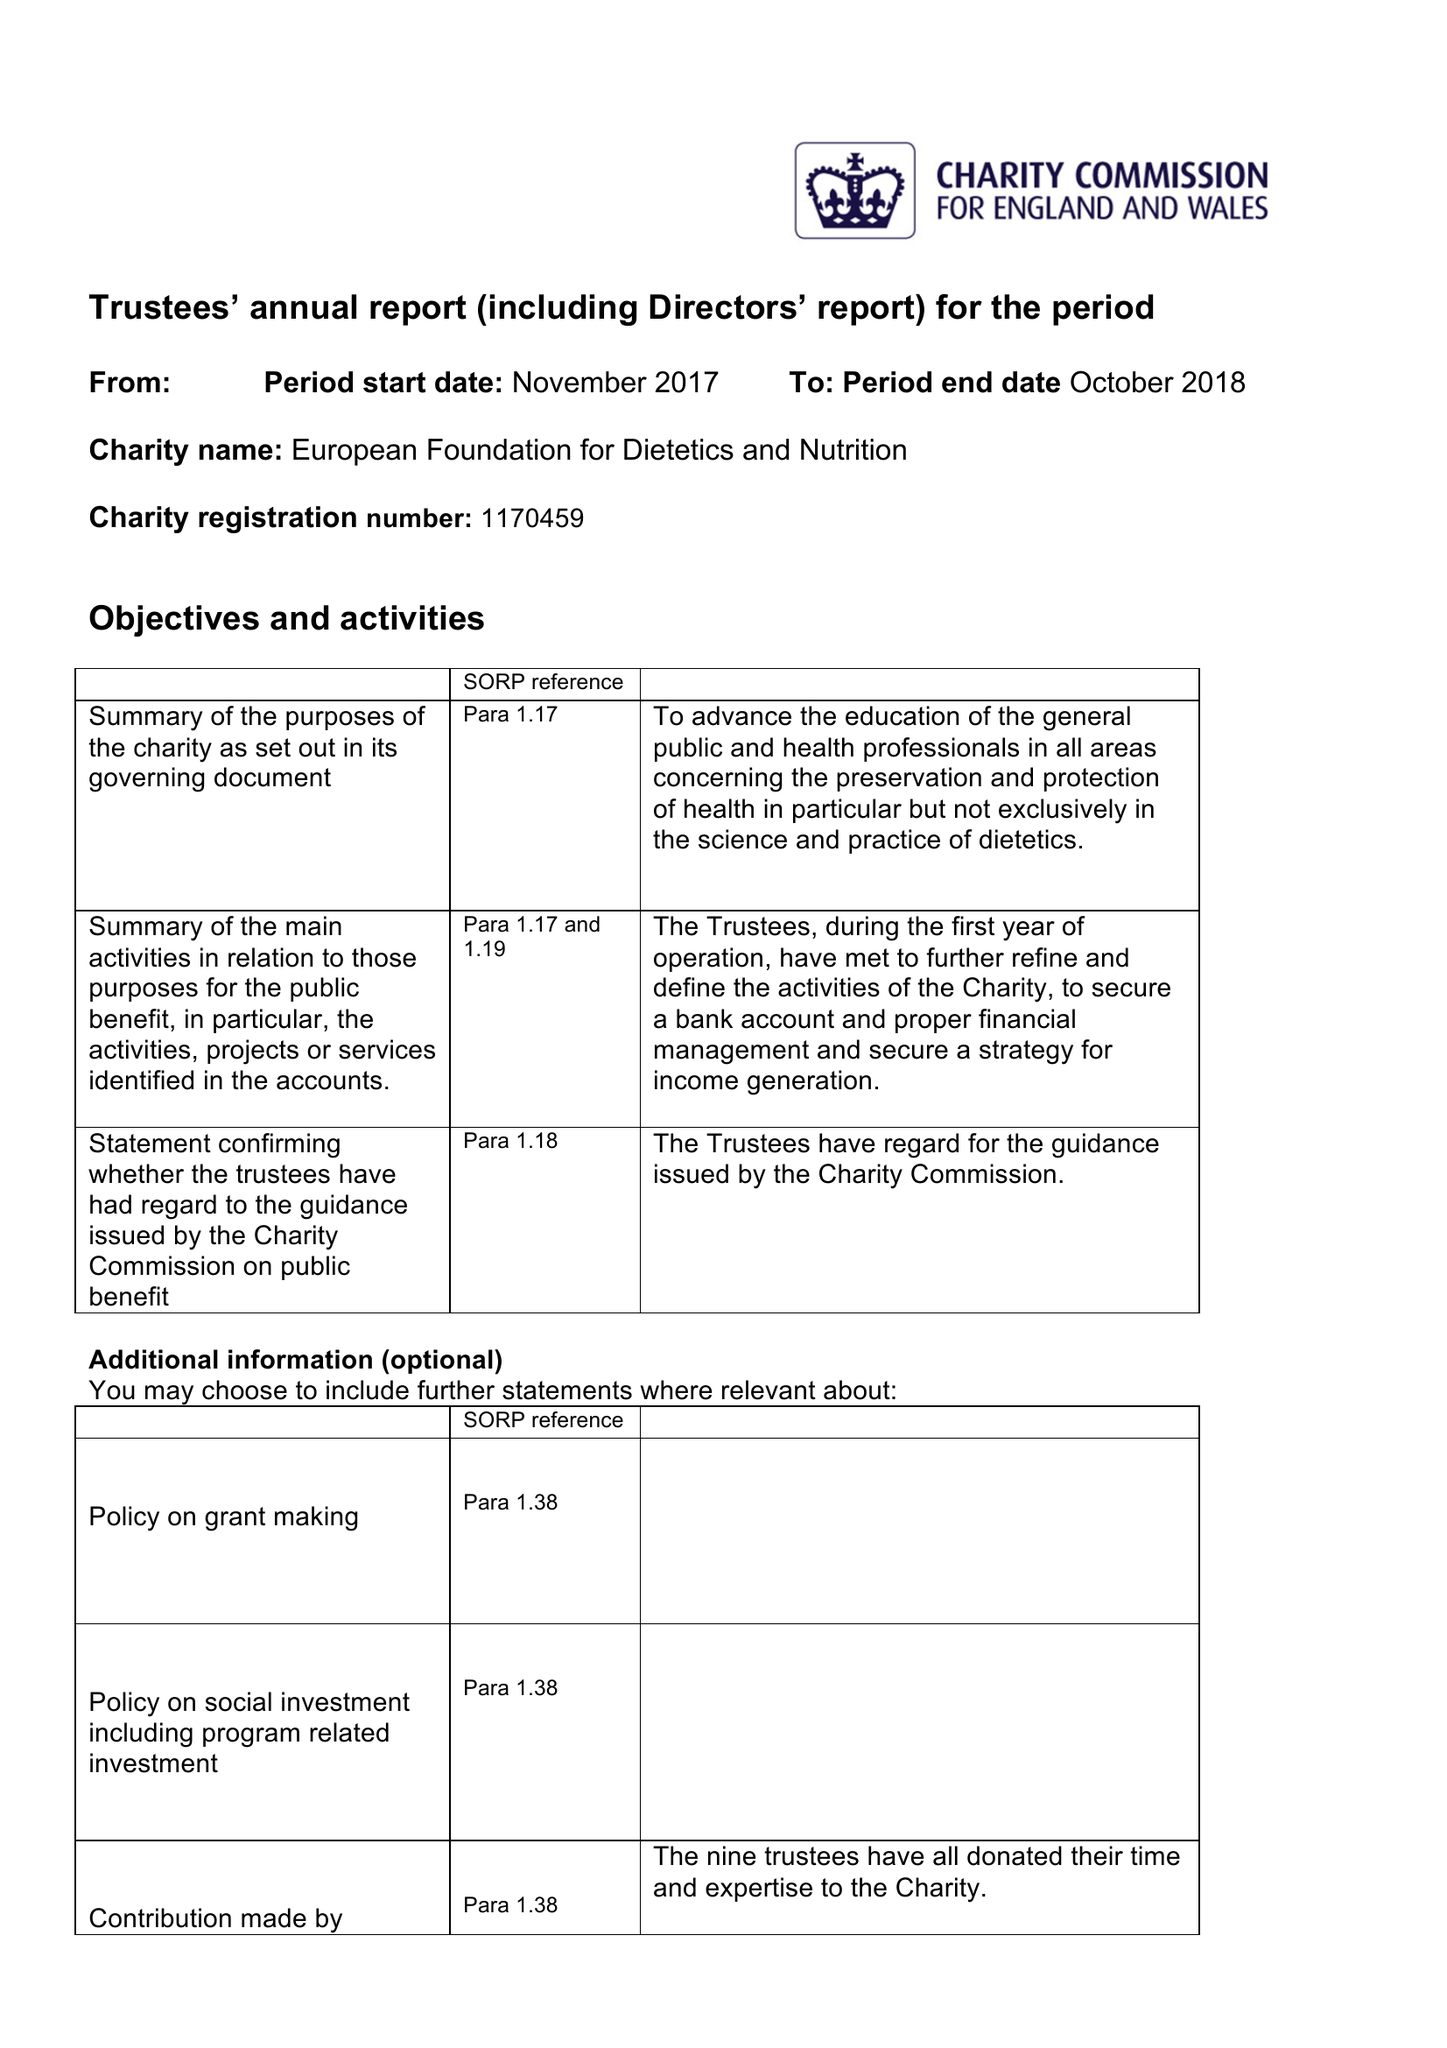What is the value for the address__post_town?
Answer the question using a single word or phrase. BIRMINGHAM 